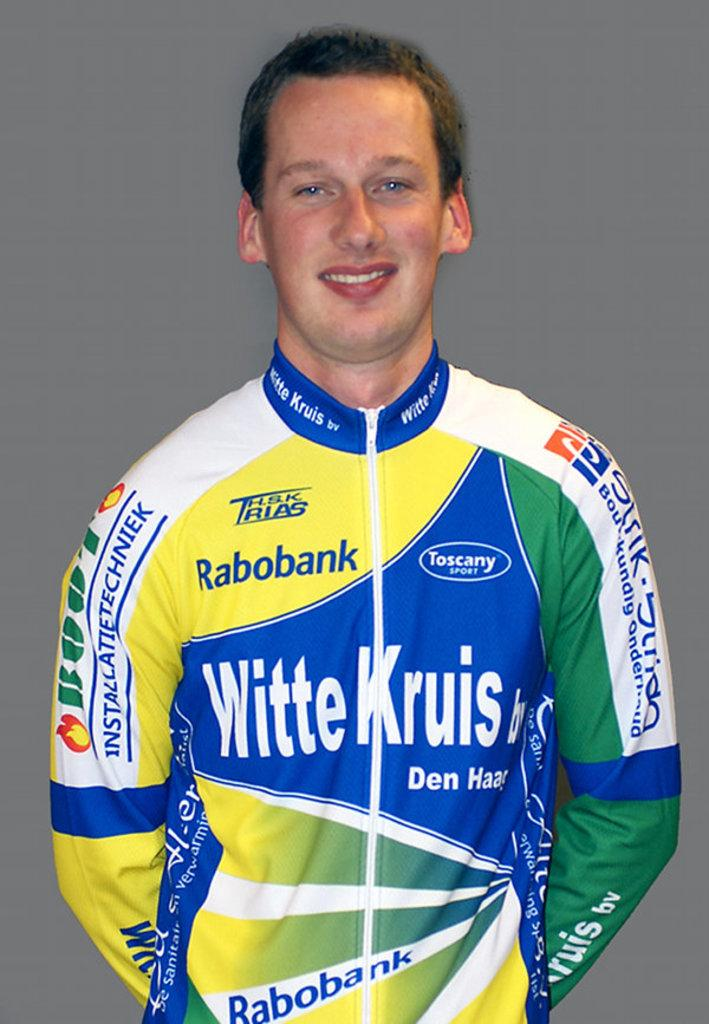<image>
Relay a brief, clear account of the picture shown. a man with a jersey from witte kruis and rabobank 